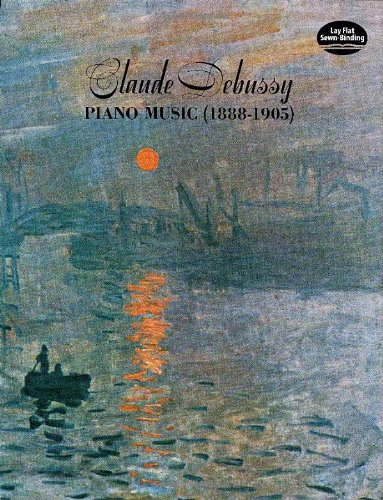What is the genre of this book? The genre of the book is best classified under 'Arts & Music', specifically focusing on classical music and piano compositions of Claude Debussy, a notable figure in Impressionist music. 